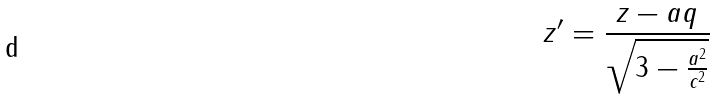Convert formula to latex. <formula><loc_0><loc_0><loc_500><loc_500>z ^ { \prime } = \frac { z - a q } { \sqrt { 3 - \frac { a ^ { 2 } } { c ^ { 2 } } } }</formula> 